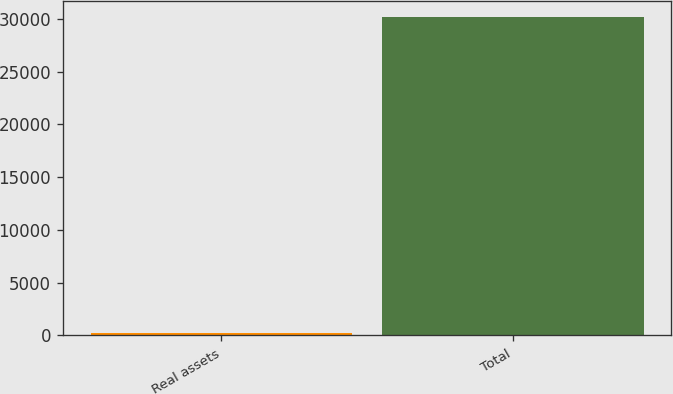Convert chart to OTSL. <chart><loc_0><loc_0><loc_500><loc_500><bar_chart><fcel>Real assets<fcel>Total<nl><fcel>253<fcel>30200<nl></chart> 